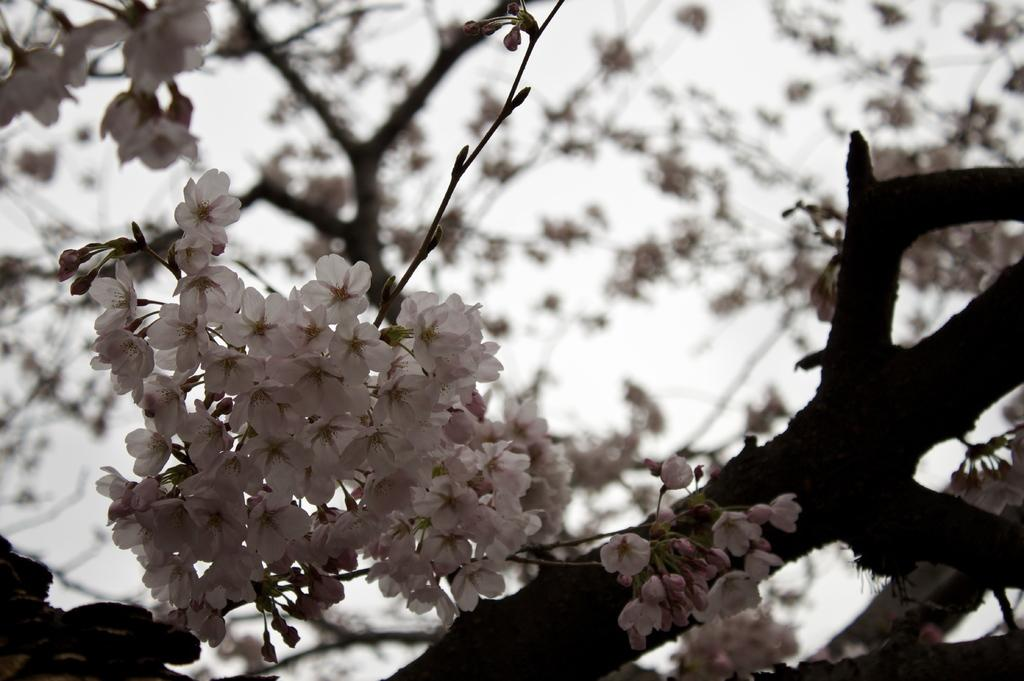What is present in the image? There is a tree in the image. What feature of the tree is mentioned in the facts? The tree has flowers. What color are the flowers on the tree? The flowers are white in color. How many chickens are sitting on the branches of the tree in the image? There are no chickens present in the image; it only features a tree with white flowers. 